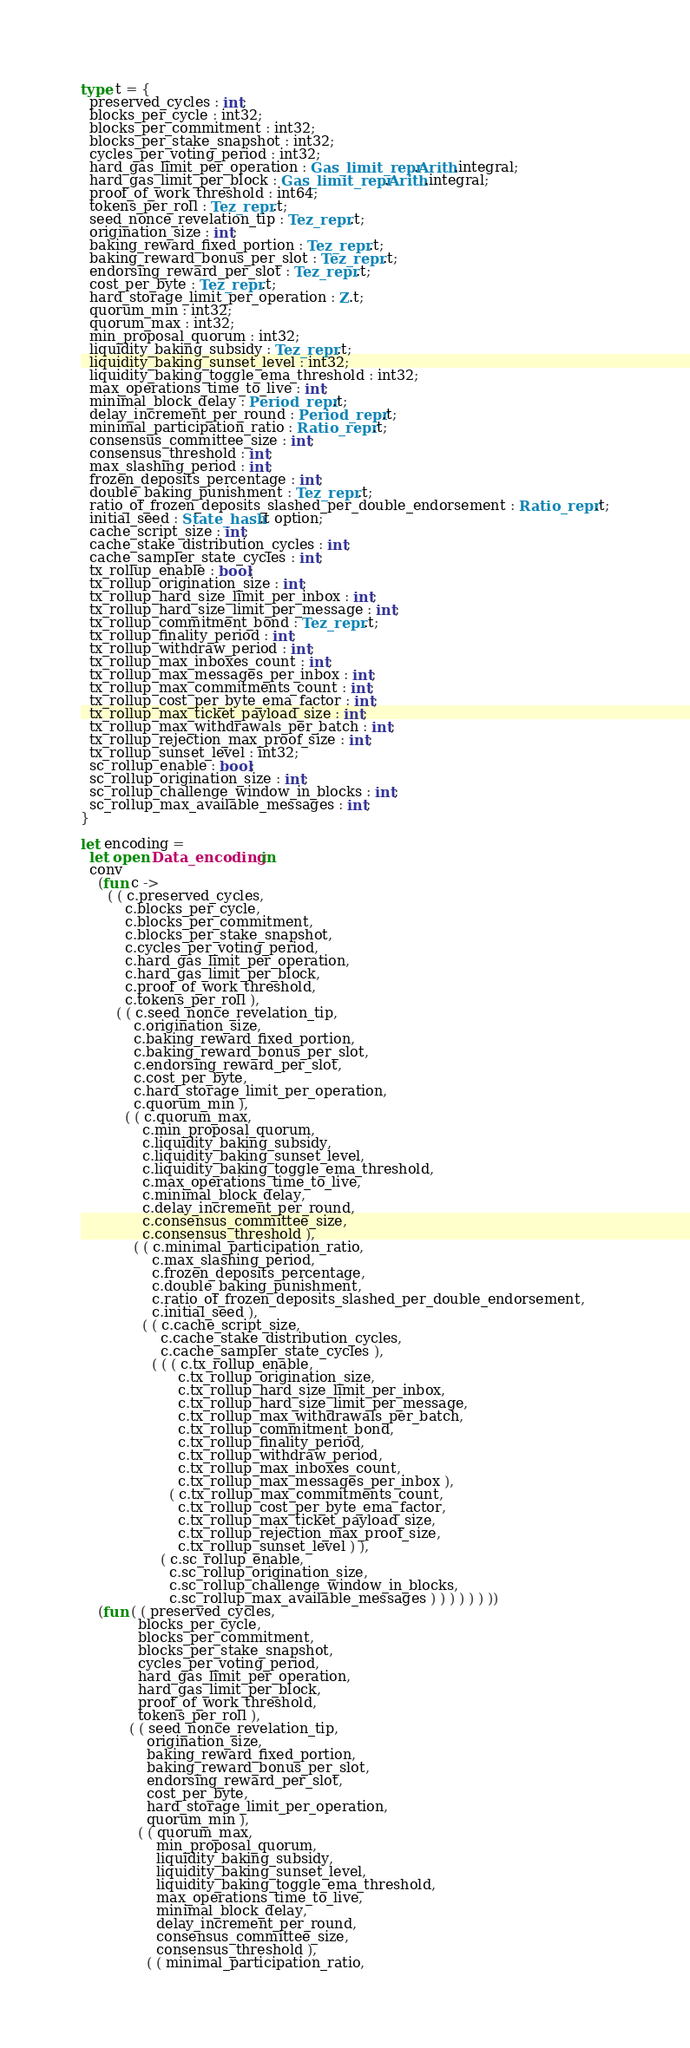<code> <loc_0><loc_0><loc_500><loc_500><_OCaml_>
type t = {
  preserved_cycles : int;
  blocks_per_cycle : int32;
  blocks_per_commitment : int32;
  blocks_per_stake_snapshot : int32;
  cycles_per_voting_period : int32;
  hard_gas_limit_per_operation : Gas_limit_repr.Arith.integral;
  hard_gas_limit_per_block : Gas_limit_repr.Arith.integral;
  proof_of_work_threshold : int64;
  tokens_per_roll : Tez_repr.t;
  seed_nonce_revelation_tip : Tez_repr.t;
  origination_size : int;
  baking_reward_fixed_portion : Tez_repr.t;
  baking_reward_bonus_per_slot : Tez_repr.t;
  endorsing_reward_per_slot : Tez_repr.t;
  cost_per_byte : Tez_repr.t;
  hard_storage_limit_per_operation : Z.t;
  quorum_min : int32;
  quorum_max : int32;
  min_proposal_quorum : int32;
  liquidity_baking_subsidy : Tez_repr.t;
  liquidity_baking_sunset_level : int32;
  liquidity_baking_toggle_ema_threshold : int32;
  max_operations_time_to_live : int;
  minimal_block_delay : Period_repr.t;
  delay_increment_per_round : Period_repr.t;
  minimal_participation_ratio : Ratio_repr.t;
  consensus_committee_size : int;
  consensus_threshold : int;
  max_slashing_period : int;
  frozen_deposits_percentage : int;
  double_baking_punishment : Tez_repr.t;
  ratio_of_frozen_deposits_slashed_per_double_endorsement : Ratio_repr.t;
  initial_seed : State_hash.t option;
  cache_script_size : int;
  cache_stake_distribution_cycles : int;
  cache_sampler_state_cycles : int;
  tx_rollup_enable : bool;
  tx_rollup_origination_size : int;
  tx_rollup_hard_size_limit_per_inbox : int;
  tx_rollup_hard_size_limit_per_message : int;
  tx_rollup_commitment_bond : Tez_repr.t;
  tx_rollup_finality_period : int;
  tx_rollup_withdraw_period : int;
  tx_rollup_max_inboxes_count : int;
  tx_rollup_max_messages_per_inbox : int;
  tx_rollup_max_commitments_count : int;
  tx_rollup_cost_per_byte_ema_factor : int;
  tx_rollup_max_ticket_payload_size : int;
  tx_rollup_max_withdrawals_per_batch : int;
  tx_rollup_rejection_max_proof_size : int;
  tx_rollup_sunset_level : int32;
  sc_rollup_enable : bool;
  sc_rollup_origination_size : int;
  sc_rollup_challenge_window_in_blocks : int;
  sc_rollup_max_available_messages : int;
}

let encoding =
  let open Data_encoding in
  conv
    (fun c ->
      ( ( c.preserved_cycles,
          c.blocks_per_cycle,
          c.blocks_per_commitment,
          c.blocks_per_stake_snapshot,
          c.cycles_per_voting_period,
          c.hard_gas_limit_per_operation,
          c.hard_gas_limit_per_block,
          c.proof_of_work_threshold,
          c.tokens_per_roll ),
        ( ( c.seed_nonce_revelation_tip,
            c.origination_size,
            c.baking_reward_fixed_portion,
            c.baking_reward_bonus_per_slot,
            c.endorsing_reward_per_slot,
            c.cost_per_byte,
            c.hard_storage_limit_per_operation,
            c.quorum_min ),
          ( ( c.quorum_max,
              c.min_proposal_quorum,
              c.liquidity_baking_subsidy,
              c.liquidity_baking_sunset_level,
              c.liquidity_baking_toggle_ema_threshold,
              c.max_operations_time_to_live,
              c.minimal_block_delay,
              c.delay_increment_per_round,
              c.consensus_committee_size,
              c.consensus_threshold ),
            ( ( c.minimal_participation_ratio,
                c.max_slashing_period,
                c.frozen_deposits_percentage,
                c.double_baking_punishment,
                c.ratio_of_frozen_deposits_slashed_per_double_endorsement,
                c.initial_seed ),
              ( ( c.cache_script_size,
                  c.cache_stake_distribution_cycles,
                  c.cache_sampler_state_cycles ),
                ( ( ( c.tx_rollup_enable,
                      c.tx_rollup_origination_size,
                      c.tx_rollup_hard_size_limit_per_inbox,
                      c.tx_rollup_hard_size_limit_per_message,
                      c.tx_rollup_max_withdrawals_per_batch,
                      c.tx_rollup_commitment_bond,
                      c.tx_rollup_finality_period,
                      c.tx_rollup_withdraw_period,
                      c.tx_rollup_max_inboxes_count,
                      c.tx_rollup_max_messages_per_inbox ),
                    ( c.tx_rollup_max_commitments_count,
                      c.tx_rollup_cost_per_byte_ema_factor,
                      c.tx_rollup_max_ticket_payload_size,
                      c.tx_rollup_rejection_max_proof_size,
                      c.tx_rollup_sunset_level ) ),
                  ( c.sc_rollup_enable,
                    c.sc_rollup_origination_size,
                    c.sc_rollup_challenge_window_in_blocks,
                    c.sc_rollup_max_available_messages ) ) ) ) ) ) ))
    (fun ( ( preserved_cycles,
             blocks_per_cycle,
             blocks_per_commitment,
             blocks_per_stake_snapshot,
             cycles_per_voting_period,
             hard_gas_limit_per_operation,
             hard_gas_limit_per_block,
             proof_of_work_threshold,
             tokens_per_roll ),
           ( ( seed_nonce_revelation_tip,
               origination_size,
               baking_reward_fixed_portion,
               baking_reward_bonus_per_slot,
               endorsing_reward_per_slot,
               cost_per_byte,
               hard_storage_limit_per_operation,
               quorum_min ),
             ( ( quorum_max,
                 min_proposal_quorum,
                 liquidity_baking_subsidy,
                 liquidity_baking_sunset_level,
                 liquidity_baking_toggle_ema_threshold,
                 max_operations_time_to_live,
                 minimal_block_delay,
                 delay_increment_per_round,
                 consensus_committee_size,
                 consensus_threshold ),
               ( ( minimal_participation_ratio,</code> 